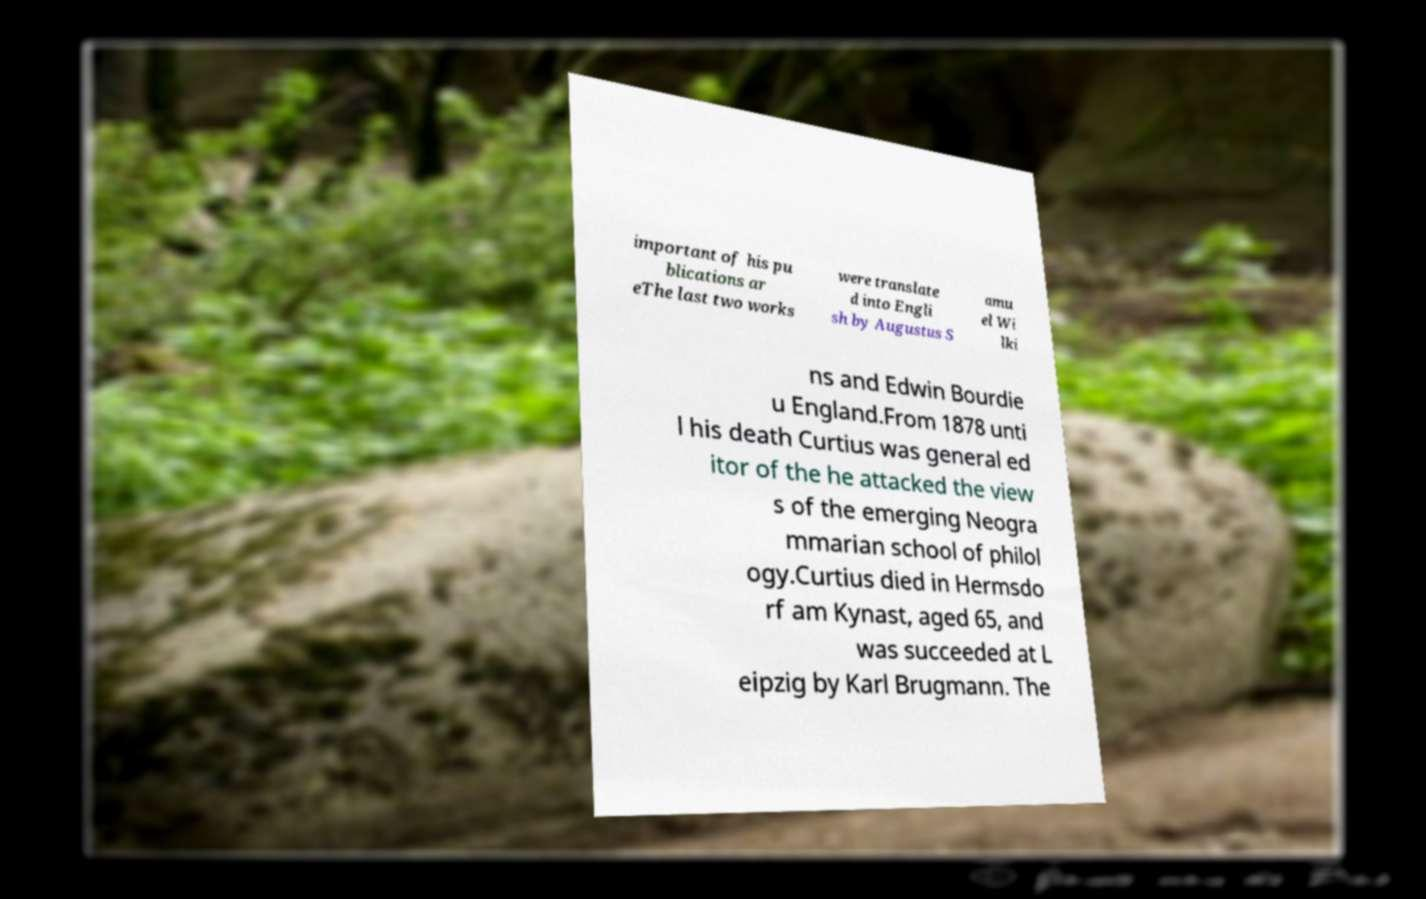Can you read and provide the text displayed in the image?This photo seems to have some interesting text. Can you extract and type it out for me? important of his pu blications ar eThe last two works were translate d into Engli sh by Augustus S amu el Wi lki ns and Edwin Bourdie u England.From 1878 unti l his death Curtius was general ed itor of the he attacked the view s of the emerging Neogra mmarian school of philol ogy.Curtius died in Hermsdo rf am Kynast, aged 65, and was succeeded at L eipzig by Karl Brugmann. The 